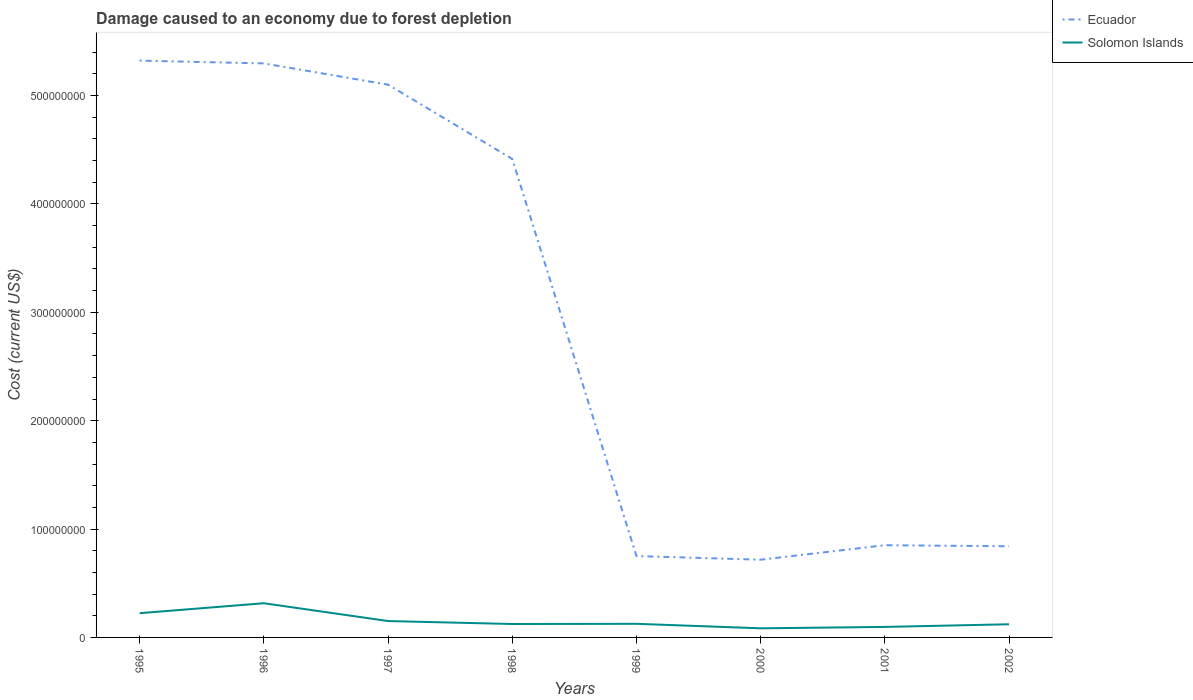Does the line corresponding to Solomon Islands intersect with the line corresponding to Ecuador?
Ensure brevity in your answer.  No. Is the number of lines equal to the number of legend labels?
Provide a short and direct response. Yes. Across all years, what is the maximum cost of damage caused due to forest depletion in Ecuador?
Offer a terse response. 7.17e+07. What is the total cost of damage caused due to forest depletion in Ecuador in the graph?
Offer a terse response. 4.46e+08. What is the difference between the highest and the second highest cost of damage caused due to forest depletion in Solomon Islands?
Keep it short and to the point. 2.31e+07. What is the difference between the highest and the lowest cost of damage caused due to forest depletion in Ecuador?
Give a very brief answer. 4. Is the cost of damage caused due to forest depletion in Ecuador strictly greater than the cost of damage caused due to forest depletion in Solomon Islands over the years?
Keep it short and to the point. No. How many lines are there?
Your answer should be very brief. 2. How many years are there in the graph?
Offer a terse response. 8. Are the values on the major ticks of Y-axis written in scientific E-notation?
Give a very brief answer. No. Does the graph contain any zero values?
Offer a very short reply. No. Does the graph contain grids?
Your response must be concise. No. What is the title of the graph?
Your answer should be compact. Damage caused to an economy due to forest depletion. What is the label or title of the X-axis?
Provide a short and direct response. Years. What is the label or title of the Y-axis?
Make the answer very short. Cost (current US$). What is the Cost (current US$) of Ecuador in 1995?
Give a very brief answer. 5.32e+08. What is the Cost (current US$) of Solomon Islands in 1995?
Ensure brevity in your answer.  2.24e+07. What is the Cost (current US$) of Ecuador in 1996?
Provide a succinct answer. 5.30e+08. What is the Cost (current US$) in Solomon Islands in 1996?
Offer a very short reply. 3.15e+07. What is the Cost (current US$) of Ecuador in 1997?
Your answer should be compact. 5.10e+08. What is the Cost (current US$) of Solomon Islands in 1997?
Give a very brief answer. 1.51e+07. What is the Cost (current US$) of Ecuador in 1998?
Keep it short and to the point. 4.42e+08. What is the Cost (current US$) of Solomon Islands in 1998?
Ensure brevity in your answer.  1.24e+07. What is the Cost (current US$) of Ecuador in 1999?
Your response must be concise. 7.51e+07. What is the Cost (current US$) in Solomon Islands in 1999?
Provide a short and direct response. 1.26e+07. What is the Cost (current US$) of Ecuador in 2000?
Provide a succinct answer. 7.17e+07. What is the Cost (current US$) in Solomon Islands in 2000?
Give a very brief answer. 8.42e+06. What is the Cost (current US$) in Ecuador in 2001?
Offer a terse response. 8.51e+07. What is the Cost (current US$) in Solomon Islands in 2001?
Your answer should be very brief. 9.69e+06. What is the Cost (current US$) in Ecuador in 2002?
Your answer should be compact. 8.41e+07. What is the Cost (current US$) of Solomon Islands in 2002?
Give a very brief answer. 1.21e+07. Across all years, what is the maximum Cost (current US$) of Ecuador?
Keep it short and to the point. 5.32e+08. Across all years, what is the maximum Cost (current US$) of Solomon Islands?
Provide a short and direct response. 3.15e+07. Across all years, what is the minimum Cost (current US$) in Ecuador?
Your answer should be compact. 7.17e+07. Across all years, what is the minimum Cost (current US$) of Solomon Islands?
Keep it short and to the point. 8.42e+06. What is the total Cost (current US$) in Ecuador in the graph?
Your answer should be very brief. 2.33e+09. What is the total Cost (current US$) in Solomon Islands in the graph?
Your answer should be very brief. 1.24e+08. What is the difference between the Cost (current US$) in Ecuador in 1995 and that in 1996?
Offer a very short reply. 2.56e+06. What is the difference between the Cost (current US$) of Solomon Islands in 1995 and that in 1996?
Offer a very short reply. -9.18e+06. What is the difference between the Cost (current US$) in Ecuador in 1995 and that in 1997?
Keep it short and to the point. 2.22e+07. What is the difference between the Cost (current US$) in Solomon Islands in 1995 and that in 1997?
Make the answer very short. 7.25e+06. What is the difference between the Cost (current US$) of Ecuador in 1995 and that in 1998?
Give a very brief answer. 9.07e+07. What is the difference between the Cost (current US$) in Solomon Islands in 1995 and that in 1998?
Your answer should be compact. 9.99e+06. What is the difference between the Cost (current US$) in Ecuador in 1995 and that in 1999?
Ensure brevity in your answer.  4.57e+08. What is the difference between the Cost (current US$) of Solomon Islands in 1995 and that in 1999?
Offer a very short reply. 9.81e+06. What is the difference between the Cost (current US$) of Ecuador in 1995 and that in 2000?
Provide a succinct answer. 4.61e+08. What is the difference between the Cost (current US$) of Solomon Islands in 1995 and that in 2000?
Offer a terse response. 1.40e+07. What is the difference between the Cost (current US$) of Ecuador in 1995 and that in 2001?
Offer a terse response. 4.47e+08. What is the difference between the Cost (current US$) in Solomon Islands in 1995 and that in 2001?
Your answer should be compact. 1.27e+07. What is the difference between the Cost (current US$) of Ecuador in 1995 and that in 2002?
Offer a terse response. 4.48e+08. What is the difference between the Cost (current US$) of Solomon Islands in 1995 and that in 2002?
Offer a very short reply. 1.02e+07. What is the difference between the Cost (current US$) of Ecuador in 1996 and that in 1997?
Make the answer very short. 1.96e+07. What is the difference between the Cost (current US$) in Solomon Islands in 1996 and that in 1997?
Offer a terse response. 1.64e+07. What is the difference between the Cost (current US$) in Ecuador in 1996 and that in 1998?
Your answer should be compact. 8.81e+07. What is the difference between the Cost (current US$) in Solomon Islands in 1996 and that in 1998?
Your answer should be compact. 1.92e+07. What is the difference between the Cost (current US$) in Ecuador in 1996 and that in 1999?
Your response must be concise. 4.55e+08. What is the difference between the Cost (current US$) in Solomon Islands in 1996 and that in 1999?
Provide a succinct answer. 1.90e+07. What is the difference between the Cost (current US$) in Ecuador in 1996 and that in 2000?
Your answer should be compact. 4.58e+08. What is the difference between the Cost (current US$) in Solomon Islands in 1996 and that in 2000?
Offer a very short reply. 2.31e+07. What is the difference between the Cost (current US$) in Ecuador in 1996 and that in 2001?
Provide a short and direct response. 4.45e+08. What is the difference between the Cost (current US$) of Solomon Islands in 1996 and that in 2001?
Offer a very short reply. 2.19e+07. What is the difference between the Cost (current US$) in Ecuador in 1996 and that in 2002?
Ensure brevity in your answer.  4.46e+08. What is the difference between the Cost (current US$) of Solomon Islands in 1996 and that in 2002?
Keep it short and to the point. 1.94e+07. What is the difference between the Cost (current US$) of Ecuador in 1997 and that in 1998?
Your response must be concise. 6.85e+07. What is the difference between the Cost (current US$) in Solomon Islands in 1997 and that in 1998?
Give a very brief answer. 2.74e+06. What is the difference between the Cost (current US$) in Ecuador in 1997 and that in 1999?
Give a very brief answer. 4.35e+08. What is the difference between the Cost (current US$) in Solomon Islands in 1997 and that in 1999?
Give a very brief answer. 2.56e+06. What is the difference between the Cost (current US$) in Ecuador in 1997 and that in 2000?
Your answer should be compact. 4.38e+08. What is the difference between the Cost (current US$) in Solomon Islands in 1997 and that in 2000?
Your answer should be very brief. 6.70e+06. What is the difference between the Cost (current US$) in Ecuador in 1997 and that in 2001?
Offer a terse response. 4.25e+08. What is the difference between the Cost (current US$) in Solomon Islands in 1997 and that in 2001?
Your answer should be very brief. 5.43e+06. What is the difference between the Cost (current US$) in Ecuador in 1997 and that in 2002?
Give a very brief answer. 4.26e+08. What is the difference between the Cost (current US$) in Solomon Islands in 1997 and that in 2002?
Offer a very short reply. 2.97e+06. What is the difference between the Cost (current US$) in Ecuador in 1998 and that in 1999?
Your response must be concise. 3.66e+08. What is the difference between the Cost (current US$) of Solomon Islands in 1998 and that in 1999?
Offer a terse response. -1.76e+05. What is the difference between the Cost (current US$) of Ecuador in 1998 and that in 2000?
Keep it short and to the point. 3.70e+08. What is the difference between the Cost (current US$) in Solomon Islands in 1998 and that in 2000?
Make the answer very short. 3.97e+06. What is the difference between the Cost (current US$) of Ecuador in 1998 and that in 2001?
Make the answer very short. 3.56e+08. What is the difference between the Cost (current US$) of Solomon Islands in 1998 and that in 2001?
Offer a very short reply. 2.69e+06. What is the difference between the Cost (current US$) of Ecuador in 1998 and that in 2002?
Keep it short and to the point. 3.57e+08. What is the difference between the Cost (current US$) in Solomon Islands in 1998 and that in 2002?
Give a very brief answer. 2.34e+05. What is the difference between the Cost (current US$) in Ecuador in 1999 and that in 2000?
Provide a short and direct response. 3.36e+06. What is the difference between the Cost (current US$) of Solomon Islands in 1999 and that in 2000?
Keep it short and to the point. 4.14e+06. What is the difference between the Cost (current US$) of Ecuador in 1999 and that in 2001?
Make the answer very short. -1.00e+07. What is the difference between the Cost (current US$) in Solomon Islands in 1999 and that in 2001?
Provide a succinct answer. 2.87e+06. What is the difference between the Cost (current US$) of Ecuador in 1999 and that in 2002?
Your response must be concise. -9.03e+06. What is the difference between the Cost (current US$) of Solomon Islands in 1999 and that in 2002?
Your response must be concise. 4.10e+05. What is the difference between the Cost (current US$) of Ecuador in 2000 and that in 2001?
Provide a short and direct response. -1.34e+07. What is the difference between the Cost (current US$) in Solomon Islands in 2000 and that in 2001?
Keep it short and to the point. -1.28e+06. What is the difference between the Cost (current US$) of Ecuador in 2000 and that in 2002?
Offer a very short reply. -1.24e+07. What is the difference between the Cost (current US$) of Solomon Islands in 2000 and that in 2002?
Ensure brevity in your answer.  -3.73e+06. What is the difference between the Cost (current US$) in Ecuador in 2001 and that in 2002?
Give a very brief answer. 9.75e+05. What is the difference between the Cost (current US$) of Solomon Islands in 2001 and that in 2002?
Make the answer very short. -2.46e+06. What is the difference between the Cost (current US$) in Ecuador in 1995 and the Cost (current US$) in Solomon Islands in 1996?
Give a very brief answer. 5.01e+08. What is the difference between the Cost (current US$) of Ecuador in 1995 and the Cost (current US$) of Solomon Islands in 1997?
Your answer should be very brief. 5.17e+08. What is the difference between the Cost (current US$) in Ecuador in 1995 and the Cost (current US$) in Solomon Islands in 1998?
Ensure brevity in your answer.  5.20e+08. What is the difference between the Cost (current US$) of Ecuador in 1995 and the Cost (current US$) of Solomon Islands in 1999?
Offer a terse response. 5.20e+08. What is the difference between the Cost (current US$) of Ecuador in 1995 and the Cost (current US$) of Solomon Islands in 2000?
Give a very brief answer. 5.24e+08. What is the difference between the Cost (current US$) in Ecuador in 1995 and the Cost (current US$) in Solomon Islands in 2001?
Make the answer very short. 5.23e+08. What is the difference between the Cost (current US$) in Ecuador in 1995 and the Cost (current US$) in Solomon Islands in 2002?
Your answer should be compact. 5.20e+08. What is the difference between the Cost (current US$) in Ecuador in 1996 and the Cost (current US$) in Solomon Islands in 1997?
Ensure brevity in your answer.  5.15e+08. What is the difference between the Cost (current US$) in Ecuador in 1996 and the Cost (current US$) in Solomon Islands in 1998?
Your answer should be compact. 5.17e+08. What is the difference between the Cost (current US$) of Ecuador in 1996 and the Cost (current US$) of Solomon Islands in 1999?
Give a very brief answer. 5.17e+08. What is the difference between the Cost (current US$) in Ecuador in 1996 and the Cost (current US$) in Solomon Islands in 2000?
Provide a succinct answer. 5.21e+08. What is the difference between the Cost (current US$) of Ecuador in 1996 and the Cost (current US$) of Solomon Islands in 2001?
Provide a succinct answer. 5.20e+08. What is the difference between the Cost (current US$) in Ecuador in 1996 and the Cost (current US$) in Solomon Islands in 2002?
Make the answer very short. 5.18e+08. What is the difference between the Cost (current US$) of Ecuador in 1997 and the Cost (current US$) of Solomon Islands in 1998?
Your answer should be compact. 4.98e+08. What is the difference between the Cost (current US$) in Ecuador in 1997 and the Cost (current US$) in Solomon Islands in 1999?
Keep it short and to the point. 4.98e+08. What is the difference between the Cost (current US$) in Ecuador in 1997 and the Cost (current US$) in Solomon Islands in 2000?
Ensure brevity in your answer.  5.02e+08. What is the difference between the Cost (current US$) in Ecuador in 1997 and the Cost (current US$) in Solomon Islands in 2001?
Offer a very short reply. 5.00e+08. What is the difference between the Cost (current US$) in Ecuador in 1997 and the Cost (current US$) in Solomon Islands in 2002?
Provide a succinct answer. 4.98e+08. What is the difference between the Cost (current US$) in Ecuador in 1998 and the Cost (current US$) in Solomon Islands in 1999?
Your answer should be very brief. 4.29e+08. What is the difference between the Cost (current US$) in Ecuador in 1998 and the Cost (current US$) in Solomon Islands in 2000?
Provide a succinct answer. 4.33e+08. What is the difference between the Cost (current US$) of Ecuador in 1998 and the Cost (current US$) of Solomon Islands in 2001?
Give a very brief answer. 4.32e+08. What is the difference between the Cost (current US$) of Ecuador in 1998 and the Cost (current US$) of Solomon Islands in 2002?
Give a very brief answer. 4.29e+08. What is the difference between the Cost (current US$) of Ecuador in 1999 and the Cost (current US$) of Solomon Islands in 2000?
Your answer should be very brief. 6.67e+07. What is the difference between the Cost (current US$) in Ecuador in 1999 and the Cost (current US$) in Solomon Islands in 2001?
Make the answer very short. 6.54e+07. What is the difference between the Cost (current US$) in Ecuador in 1999 and the Cost (current US$) in Solomon Islands in 2002?
Provide a short and direct response. 6.29e+07. What is the difference between the Cost (current US$) in Ecuador in 2000 and the Cost (current US$) in Solomon Islands in 2001?
Your response must be concise. 6.20e+07. What is the difference between the Cost (current US$) in Ecuador in 2000 and the Cost (current US$) in Solomon Islands in 2002?
Provide a short and direct response. 5.96e+07. What is the difference between the Cost (current US$) of Ecuador in 2001 and the Cost (current US$) of Solomon Islands in 2002?
Your response must be concise. 7.29e+07. What is the average Cost (current US$) in Ecuador per year?
Your answer should be compact. 2.91e+08. What is the average Cost (current US$) in Solomon Islands per year?
Your response must be concise. 1.55e+07. In the year 1995, what is the difference between the Cost (current US$) of Ecuador and Cost (current US$) of Solomon Islands?
Offer a very short reply. 5.10e+08. In the year 1996, what is the difference between the Cost (current US$) in Ecuador and Cost (current US$) in Solomon Islands?
Give a very brief answer. 4.98e+08. In the year 1997, what is the difference between the Cost (current US$) of Ecuador and Cost (current US$) of Solomon Islands?
Keep it short and to the point. 4.95e+08. In the year 1998, what is the difference between the Cost (current US$) of Ecuador and Cost (current US$) of Solomon Islands?
Ensure brevity in your answer.  4.29e+08. In the year 1999, what is the difference between the Cost (current US$) in Ecuador and Cost (current US$) in Solomon Islands?
Offer a very short reply. 6.25e+07. In the year 2000, what is the difference between the Cost (current US$) in Ecuador and Cost (current US$) in Solomon Islands?
Provide a short and direct response. 6.33e+07. In the year 2001, what is the difference between the Cost (current US$) of Ecuador and Cost (current US$) of Solomon Islands?
Provide a short and direct response. 7.54e+07. In the year 2002, what is the difference between the Cost (current US$) of Ecuador and Cost (current US$) of Solomon Islands?
Ensure brevity in your answer.  7.20e+07. What is the ratio of the Cost (current US$) in Solomon Islands in 1995 to that in 1996?
Provide a short and direct response. 0.71. What is the ratio of the Cost (current US$) in Ecuador in 1995 to that in 1997?
Provide a succinct answer. 1.04. What is the ratio of the Cost (current US$) in Solomon Islands in 1995 to that in 1997?
Give a very brief answer. 1.48. What is the ratio of the Cost (current US$) in Ecuador in 1995 to that in 1998?
Make the answer very short. 1.21. What is the ratio of the Cost (current US$) of Solomon Islands in 1995 to that in 1998?
Your response must be concise. 1.81. What is the ratio of the Cost (current US$) in Ecuador in 1995 to that in 1999?
Offer a very short reply. 7.09. What is the ratio of the Cost (current US$) of Solomon Islands in 1995 to that in 1999?
Your answer should be very brief. 1.78. What is the ratio of the Cost (current US$) of Ecuador in 1995 to that in 2000?
Provide a succinct answer. 7.42. What is the ratio of the Cost (current US$) of Solomon Islands in 1995 to that in 2000?
Provide a succinct answer. 2.66. What is the ratio of the Cost (current US$) of Ecuador in 1995 to that in 2001?
Provide a short and direct response. 6.26. What is the ratio of the Cost (current US$) in Solomon Islands in 1995 to that in 2001?
Keep it short and to the point. 2.31. What is the ratio of the Cost (current US$) of Ecuador in 1995 to that in 2002?
Provide a succinct answer. 6.33. What is the ratio of the Cost (current US$) of Solomon Islands in 1995 to that in 2002?
Provide a short and direct response. 1.84. What is the ratio of the Cost (current US$) of Ecuador in 1996 to that in 1997?
Offer a terse response. 1.04. What is the ratio of the Cost (current US$) of Solomon Islands in 1996 to that in 1997?
Offer a terse response. 2.09. What is the ratio of the Cost (current US$) of Ecuador in 1996 to that in 1998?
Offer a very short reply. 1.2. What is the ratio of the Cost (current US$) in Solomon Islands in 1996 to that in 1998?
Your response must be concise. 2.55. What is the ratio of the Cost (current US$) of Ecuador in 1996 to that in 1999?
Give a very brief answer. 7.05. What is the ratio of the Cost (current US$) of Solomon Islands in 1996 to that in 1999?
Your response must be concise. 2.51. What is the ratio of the Cost (current US$) in Ecuador in 1996 to that in 2000?
Offer a terse response. 7.39. What is the ratio of the Cost (current US$) of Solomon Islands in 1996 to that in 2000?
Ensure brevity in your answer.  3.75. What is the ratio of the Cost (current US$) in Ecuador in 1996 to that in 2001?
Offer a terse response. 6.23. What is the ratio of the Cost (current US$) in Solomon Islands in 1996 to that in 2001?
Offer a very short reply. 3.25. What is the ratio of the Cost (current US$) in Ecuador in 1996 to that in 2002?
Make the answer very short. 6.3. What is the ratio of the Cost (current US$) in Solomon Islands in 1996 to that in 2002?
Give a very brief answer. 2.6. What is the ratio of the Cost (current US$) of Ecuador in 1997 to that in 1998?
Offer a very short reply. 1.16. What is the ratio of the Cost (current US$) of Solomon Islands in 1997 to that in 1998?
Offer a very short reply. 1.22. What is the ratio of the Cost (current US$) in Ecuador in 1997 to that in 1999?
Your answer should be compact. 6.79. What is the ratio of the Cost (current US$) in Solomon Islands in 1997 to that in 1999?
Provide a succinct answer. 1.2. What is the ratio of the Cost (current US$) of Ecuador in 1997 to that in 2000?
Your answer should be compact. 7.11. What is the ratio of the Cost (current US$) in Solomon Islands in 1997 to that in 2000?
Ensure brevity in your answer.  1.8. What is the ratio of the Cost (current US$) in Ecuador in 1997 to that in 2001?
Your response must be concise. 5.99. What is the ratio of the Cost (current US$) of Solomon Islands in 1997 to that in 2001?
Provide a succinct answer. 1.56. What is the ratio of the Cost (current US$) in Ecuador in 1997 to that in 2002?
Provide a succinct answer. 6.06. What is the ratio of the Cost (current US$) in Solomon Islands in 1997 to that in 2002?
Ensure brevity in your answer.  1.24. What is the ratio of the Cost (current US$) in Ecuador in 1998 to that in 1999?
Ensure brevity in your answer.  5.88. What is the ratio of the Cost (current US$) in Ecuador in 1998 to that in 2000?
Your response must be concise. 6.16. What is the ratio of the Cost (current US$) of Solomon Islands in 1998 to that in 2000?
Your response must be concise. 1.47. What is the ratio of the Cost (current US$) in Ecuador in 1998 to that in 2001?
Provide a short and direct response. 5.19. What is the ratio of the Cost (current US$) of Solomon Islands in 1998 to that in 2001?
Provide a short and direct response. 1.28. What is the ratio of the Cost (current US$) in Ecuador in 1998 to that in 2002?
Offer a terse response. 5.25. What is the ratio of the Cost (current US$) in Solomon Islands in 1998 to that in 2002?
Provide a succinct answer. 1.02. What is the ratio of the Cost (current US$) in Ecuador in 1999 to that in 2000?
Provide a short and direct response. 1.05. What is the ratio of the Cost (current US$) of Solomon Islands in 1999 to that in 2000?
Make the answer very short. 1.49. What is the ratio of the Cost (current US$) in Ecuador in 1999 to that in 2001?
Offer a very short reply. 0.88. What is the ratio of the Cost (current US$) in Solomon Islands in 1999 to that in 2001?
Give a very brief answer. 1.3. What is the ratio of the Cost (current US$) of Ecuador in 1999 to that in 2002?
Your response must be concise. 0.89. What is the ratio of the Cost (current US$) in Solomon Islands in 1999 to that in 2002?
Give a very brief answer. 1.03. What is the ratio of the Cost (current US$) of Ecuador in 2000 to that in 2001?
Keep it short and to the point. 0.84. What is the ratio of the Cost (current US$) in Solomon Islands in 2000 to that in 2001?
Offer a very short reply. 0.87. What is the ratio of the Cost (current US$) in Ecuador in 2000 to that in 2002?
Offer a very short reply. 0.85. What is the ratio of the Cost (current US$) of Solomon Islands in 2000 to that in 2002?
Keep it short and to the point. 0.69. What is the ratio of the Cost (current US$) in Ecuador in 2001 to that in 2002?
Your answer should be compact. 1.01. What is the ratio of the Cost (current US$) in Solomon Islands in 2001 to that in 2002?
Provide a succinct answer. 0.8. What is the difference between the highest and the second highest Cost (current US$) in Ecuador?
Offer a very short reply. 2.56e+06. What is the difference between the highest and the second highest Cost (current US$) in Solomon Islands?
Offer a terse response. 9.18e+06. What is the difference between the highest and the lowest Cost (current US$) in Ecuador?
Offer a terse response. 4.61e+08. What is the difference between the highest and the lowest Cost (current US$) of Solomon Islands?
Your answer should be very brief. 2.31e+07. 